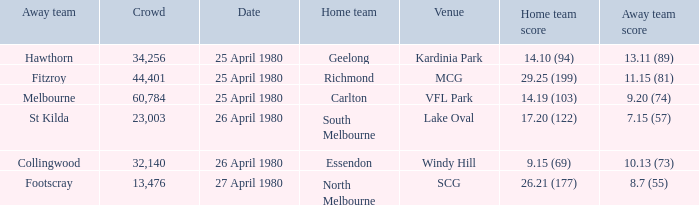On what date did the match at Lake Oval take place? 26 April 1980. Give me the full table as a dictionary. {'header': ['Away team', 'Crowd', 'Date', 'Home team', 'Venue', 'Home team score', 'Away team score'], 'rows': [['Hawthorn', '34,256', '25 April 1980', 'Geelong', 'Kardinia Park', '14.10 (94)', '13.11 (89)'], ['Fitzroy', '44,401', '25 April 1980', 'Richmond', 'MCG', '29.25 (199)', '11.15 (81)'], ['Melbourne', '60,784', '25 April 1980', 'Carlton', 'VFL Park', '14.19 (103)', '9.20 (74)'], ['St Kilda', '23,003', '26 April 1980', 'South Melbourne', 'Lake Oval', '17.20 (122)', '7.15 (57)'], ['Collingwood', '32,140', '26 April 1980', 'Essendon', 'Windy Hill', '9.15 (69)', '10.13 (73)'], ['Footscray', '13,476', '27 April 1980', 'North Melbourne', 'SCG', '26.21 (177)', '8.7 (55)']]} 